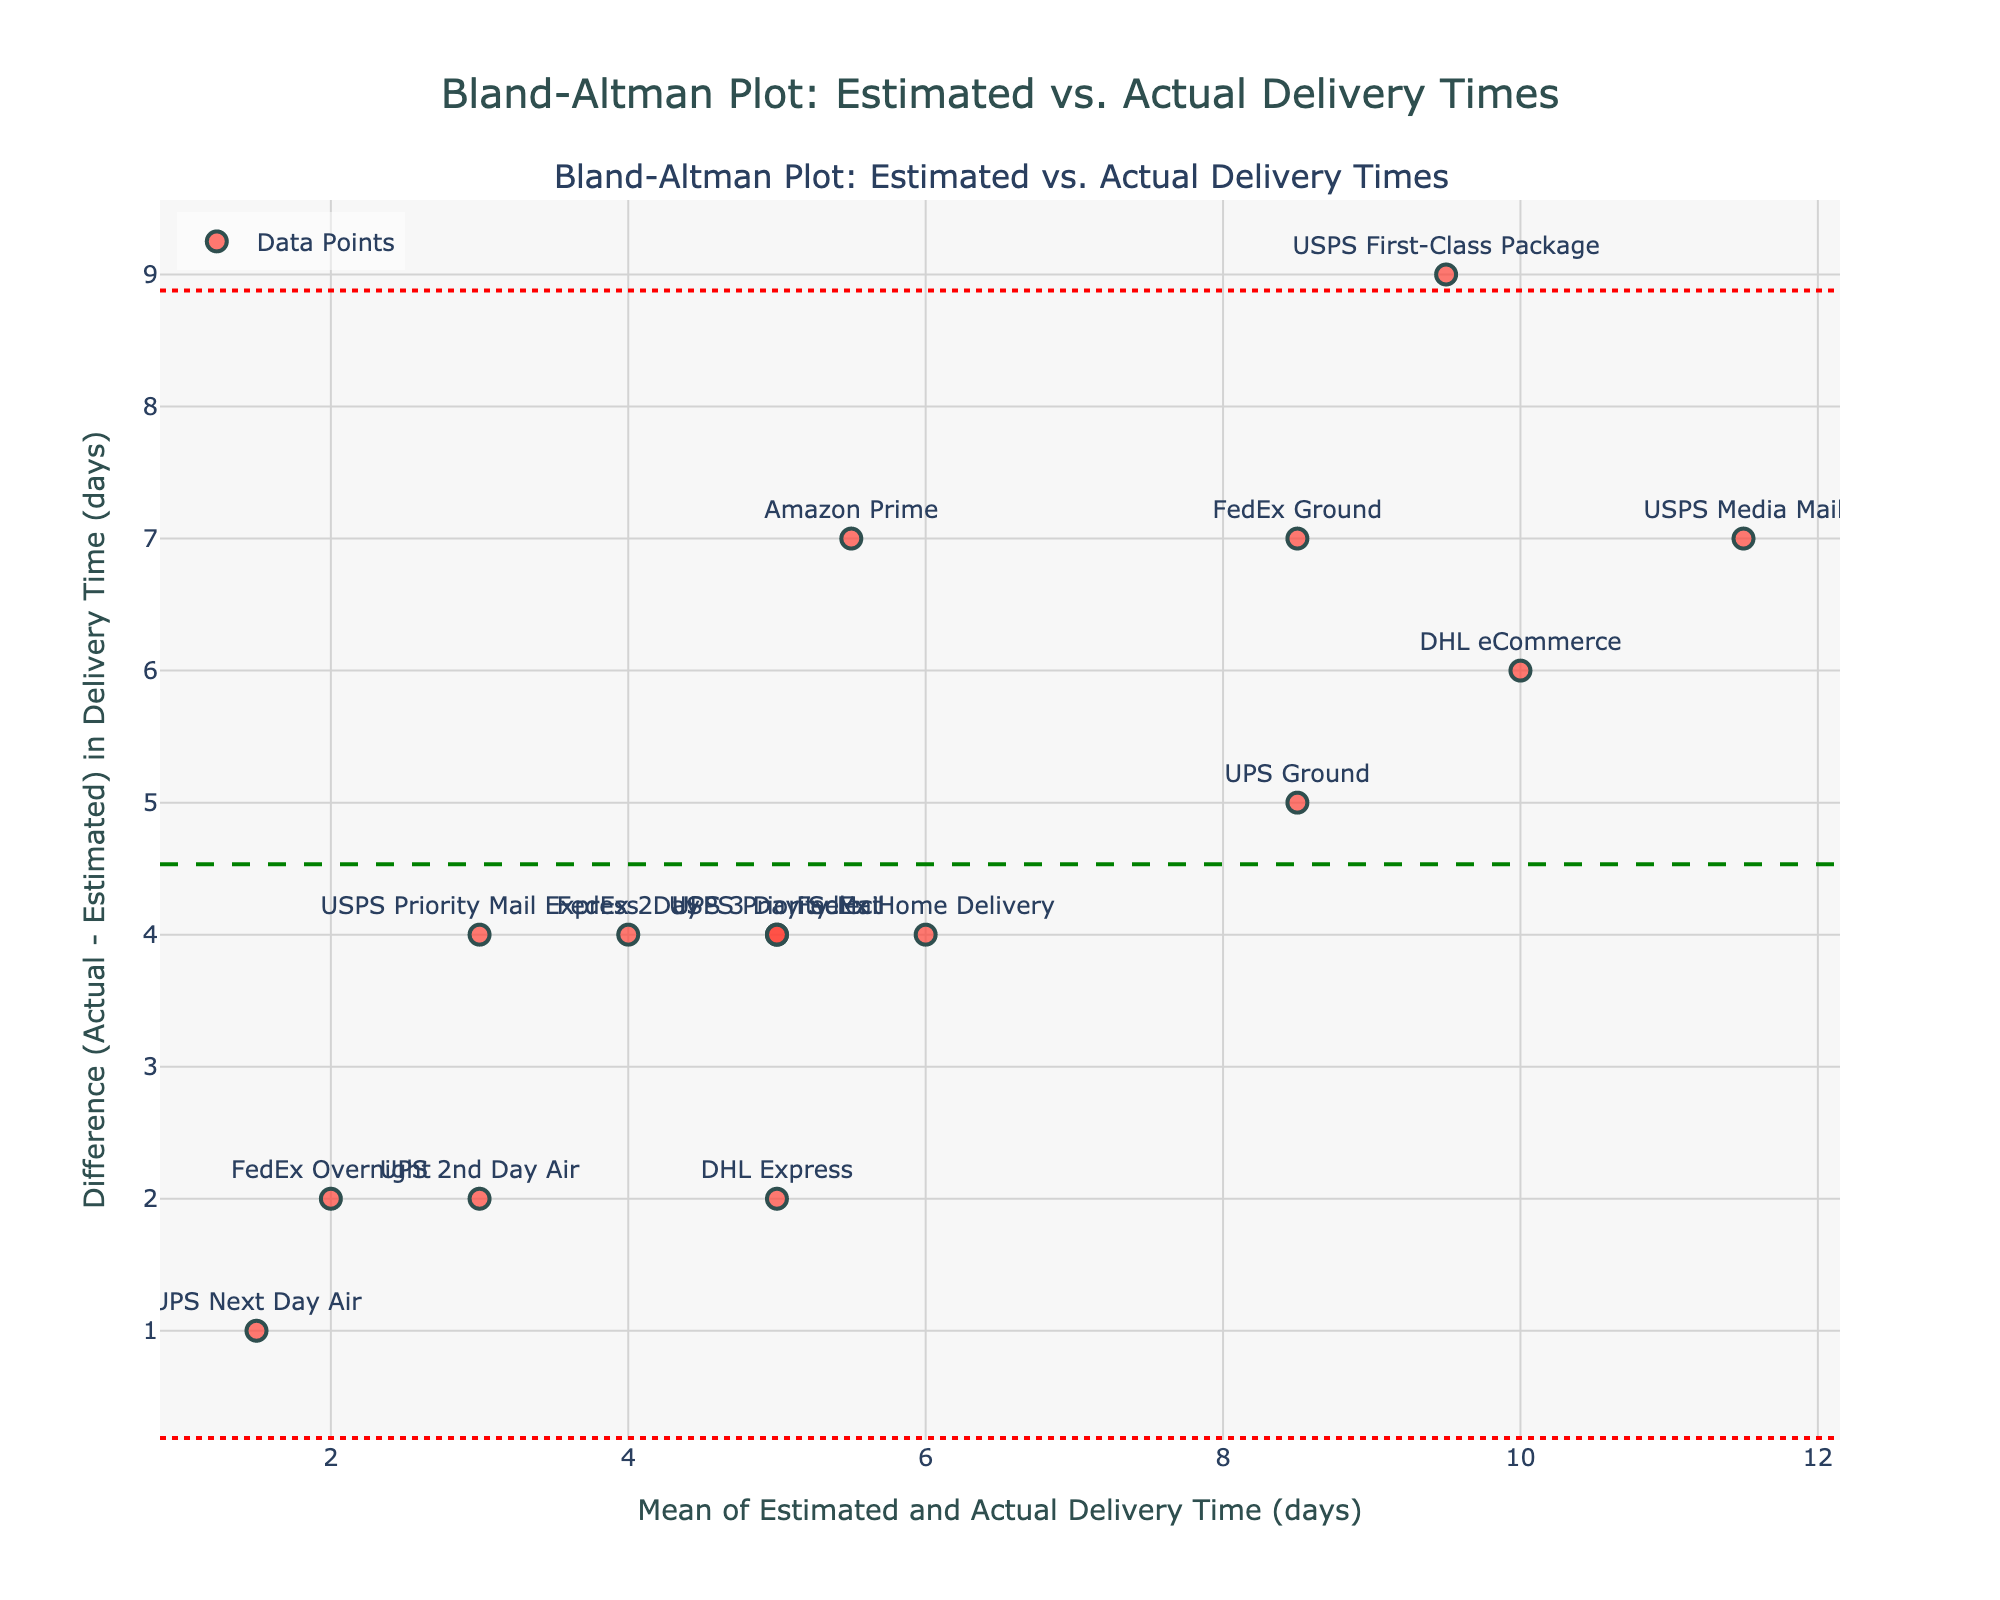Which shipping method has the largest difference between estimated and actual delivery times? The largest difference can be identified by looking for the shipping method with the highest value on the y-axis. In this case, it is USPS First-Class Package with a difference of 9 days.
Answer: USPS First-Class Package What is the mean difference between estimated and actual delivery times for all shipping methods? The mean difference is shown by the horizontal green dashed line on the plot, indicating how much the actual delivery times differ, on average, from the estimated delivery times. This value is visually indicated around 4.6 days.
Answer: 4.6 days Which shipping method has the smallest difference between estimated and actual delivery times? The smallest difference is identified by finding the shipping method with the lowest y-axis value. UPS Next Day Air has the smallest difference, which is 1 day.
Answer: UPS Next Day Air What are the upper and lower limits of agreement on the plot? The upper and lower limits of agreement are represented by the red dotted lines. The upper limit is approximately 10.76 days, and the lower limit is approximately -1.56 days. This range captures most differences between estimated and actual delivery times.
Answer: Upper: 10.76 days, Lower: -1.56 days Which shipping methods fall outside the limits of agreement? To determine which shipping methods fall outside the limits of agreement, look for the data points (markers) that are above the upper limit line or below the lower limit line. In this case, USPS First-Class Package exceeds the upper limit.
Answer: USPS First-Class Package What is the average of the estimated and actual delivery times for DHL eCommerce? The x-axis represents the mean of the estimated and actual delivery times. For DHL eCommerce, the mean is calculated as (7 + 13) / 2 = 10 days.
Answer: 10 days Explain the significance of the horizontal lines (mean difference and limits of agreement) in the Bland-Altman plot. The mean difference line (green dashed) represents the average difference between estimated and actual delivery times, indicating overall bias. The limits of agreement (red dotted) indicate the range where most differences lie, helping to assess the agreement between methods. If most points are within these limits, the methods are considered to have good agreement.
Answer: Mean difference shows bias; limits of agreement assess how well methods agree Which shipping method has a mean value (average of estimated and actual delivery times) close to 5 days? What's its difference? Locate the data point closest to 5 days on the x-axis (mean value). For USPS Priority Mail, the mean is close to 5 days; the actual difference is 4 days.
Answer: USPS Priority Mail, 4 days What can you say about the overall trend in the differences between estimated and actual delivery times? By examining the plot, most data points show positive differences (above the x-axis), suggesting that actual delivery times are generally longer than estimated delivery times across shipping methods.
Answer: Actual delivery times are generally longer 